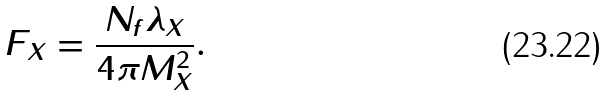Convert formula to latex. <formula><loc_0><loc_0><loc_500><loc_500>F _ { X } = \frac { N _ { f } \lambda _ { X } } { 4 \pi M _ { X } ^ { 2 } } .</formula> 